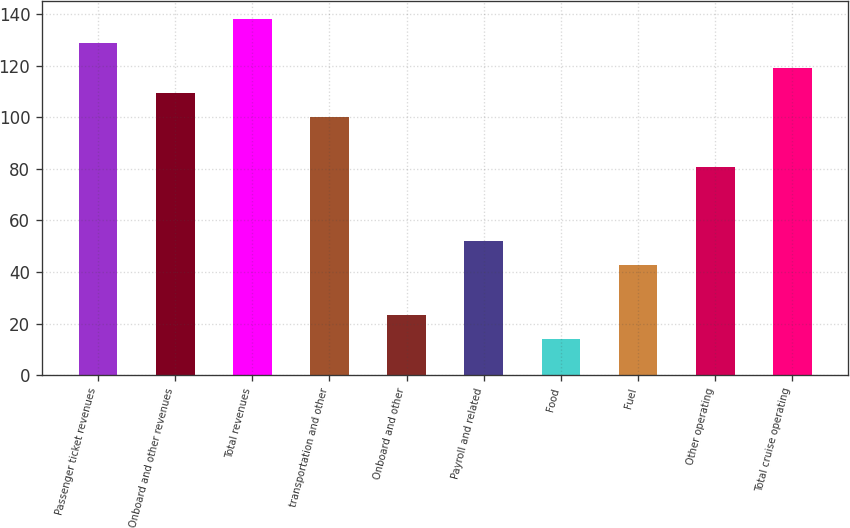Convert chart to OTSL. <chart><loc_0><loc_0><loc_500><loc_500><bar_chart><fcel>Passenger ticket revenues<fcel>Onboard and other revenues<fcel>Total revenues<fcel>transportation and other<fcel>Onboard and other<fcel>Payroll and related<fcel>Food<fcel>Fuel<fcel>Other operating<fcel>Total cruise operating<nl><fcel>128.71<fcel>109.57<fcel>138.28<fcel>100<fcel>23.44<fcel>52.15<fcel>13.87<fcel>42.58<fcel>80.86<fcel>119.14<nl></chart> 